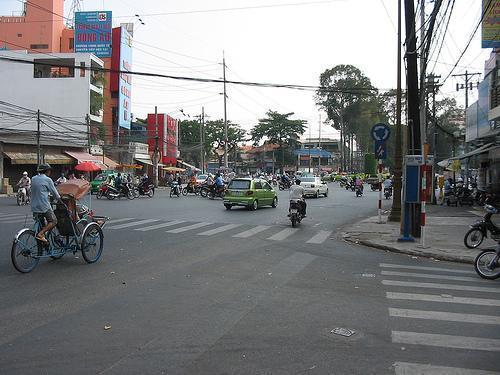How many green cars are there?
Give a very brief answer. 2. 